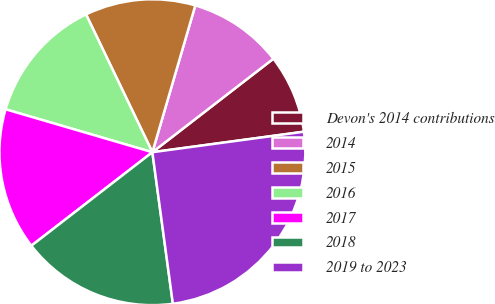Convert chart to OTSL. <chart><loc_0><loc_0><loc_500><loc_500><pie_chart><fcel>Devon's 2014 contributions<fcel>2014<fcel>2015<fcel>2016<fcel>2017<fcel>2018<fcel>2019 to 2023<nl><fcel>8.33%<fcel>10.0%<fcel>11.67%<fcel>13.33%<fcel>15.0%<fcel>16.67%<fcel>25.0%<nl></chart> 